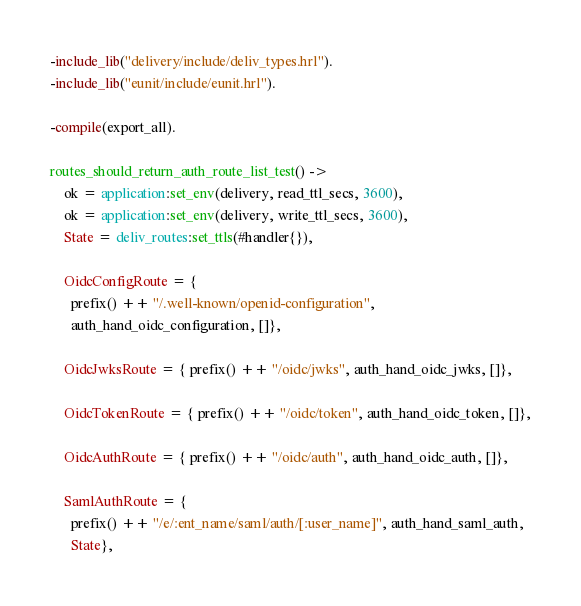<code> <loc_0><loc_0><loc_500><loc_500><_Erlang_>-include_lib("delivery/include/deliv_types.hrl").
-include_lib("eunit/include/eunit.hrl").

-compile(export_all).

routes_should_return_auth_route_list_test() ->
    ok = application:set_env(delivery, read_ttl_secs, 3600),
    ok = application:set_env(delivery, write_ttl_secs, 3600),
    State = deliv_routes:set_ttls(#handler{}),

    OidcConfigRoute = {
      prefix() ++ "/.well-known/openid-configuration",
      auth_hand_oidc_configuration, []},

    OidcJwksRoute = { prefix() ++ "/oidc/jwks", auth_hand_oidc_jwks, []},

    OidcTokenRoute = { prefix() ++ "/oidc/token", auth_hand_oidc_token, []},

    OidcAuthRoute = { prefix() ++ "/oidc/auth", auth_hand_oidc_auth, []},

    SamlAuthRoute = {
      prefix() ++ "/e/:ent_name/saml/auth/[:user_name]", auth_hand_saml_auth,
      State},
</code> 